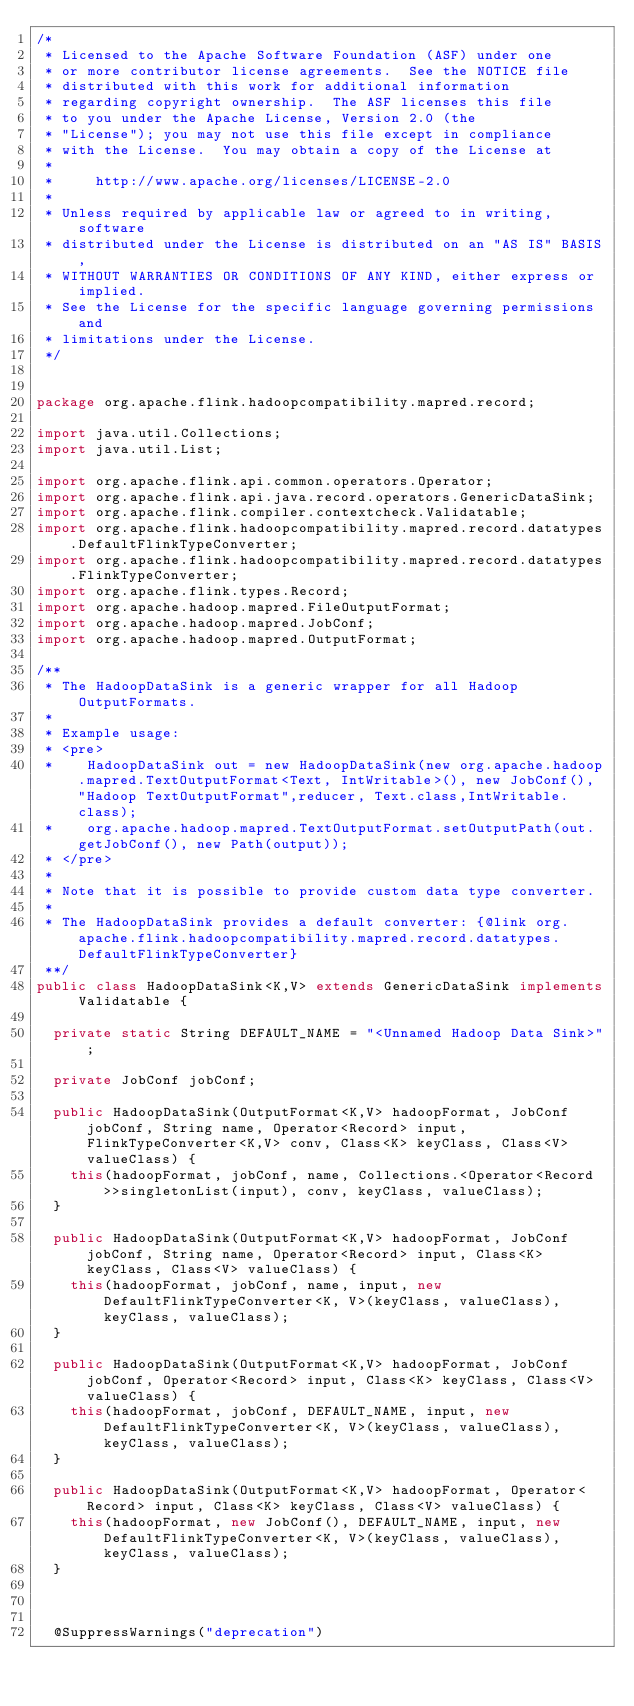Convert code to text. <code><loc_0><loc_0><loc_500><loc_500><_Java_>/*
 * Licensed to the Apache Software Foundation (ASF) under one
 * or more contributor license agreements.  See the NOTICE file
 * distributed with this work for additional information
 * regarding copyright ownership.  The ASF licenses this file
 * to you under the Apache License, Version 2.0 (the
 * "License"); you may not use this file except in compliance
 * with the License.  You may obtain a copy of the License at
 *
 *     http://www.apache.org/licenses/LICENSE-2.0
 *
 * Unless required by applicable law or agreed to in writing, software
 * distributed under the License is distributed on an "AS IS" BASIS,
 * WITHOUT WARRANTIES OR CONDITIONS OF ANY KIND, either express or implied.
 * See the License for the specific language governing permissions and
 * limitations under the License.
 */


package org.apache.flink.hadoopcompatibility.mapred.record;

import java.util.Collections;
import java.util.List;

import org.apache.flink.api.common.operators.Operator;
import org.apache.flink.api.java.record.operators.GenericDataSink;
import org.apache.flink.compiler.contextcheck.Validatable;
import org.apache.flink.hadoopcompatibility.mapred.record.datatypes.DefaultFlinkTypeConverter;
import org.apache.flink.hadoopcompatibility.mapred.record.datatypes.FlinkTypeConverter;
import org.apache.flink.types.Record;
import org.apache.hadoop.mapred.FileOutputFormat;
import org.apache.hadoop.mapred.JobConf;
import org.apache.hadoop.mapred.OutputFormat;

/**
 * The HadoopDataSink is a generic wrapper for all Hadoop OutputFormats.
 *
 * Example usage:
 * <pre>
 * 		HadoopDataSink out = new HadoopDataSink(new org.apache.hadoop.mapred.TextOutputFormat<Text, IntWritable>(), new JobConf(), "Hadoop TextOutputFormat",reducer, Text.class,IntWritable.class);
 *		org.apache.hadoop.mapred.TextOutputFormat.setOutputPath(out.getJobConf(), new Path(output));
 * </pre>
 *
 * Note that it is possible to provide custom data type converter.
 *
 * The HadoopDataSink provides a default converter: {@link org.apache.flink.hadoopcompatibility.mapred.record.datatypes.DefaultFlinkTypeConverter}
 **/
public class HadoopDataSink<K,V> extends GenericDataSink implements Validatable {

	private static String DEFAULT_NAME = "<Unnamed Hadoop Data Sink>";

	private JobConf jobConf;

	public HadoopDataSink(OutputFormat<K,V> hadoopFormat, JobConf jobConf, String name, Operator<Record> input, FlinkTypeConverter<K,V> conv, Class<K> keyClass, Class<V> valueClass) {
		this(hadoopFormat, jobConf, name, Collections.<Operator<Record>>singletonList(input), conv, keyClass, valueClass);
	}

	public HadoopDataSink(OutputFormat<K,V> hadoopFormat, JobConf jobConf, String name, Operator<Record> input, Class<K> keyClass, Class<V> valueClass) {
		this(hadoopFormat, jobConf, name, input, new DefaultFlinkTypeConverter<K, V>(keyClass, valueClass), keyClass, valueClass);
	}

	public HadoopDataSink(OutputFormat<K,V> hadoopFormat, JobConf jobConf, Operator<Record> input, Class<K> keyClass, Class<V> valueClass) {
		this(hadoopFormat, jobConf, DEFAULT_NAME, input, new DefaultFlinkTypeConverter<K, V>(keyClass, valueClass), keyClass, valueClass);
	}

	public HadoopDataSink(OutputFormat<K,V> hadoopFormat, Operator<Record> input, Class<K> keyClass, Class<V> valueClass) {
		this(hadoopFormat, new JobConf(), DEFAULT_NAME, input, new DefaultFlinkTypeConverter<K, V>(keyClass, valueClass), keyClass, valueClass);
	}



	@SuppressWarnings("deprecation")</code> 